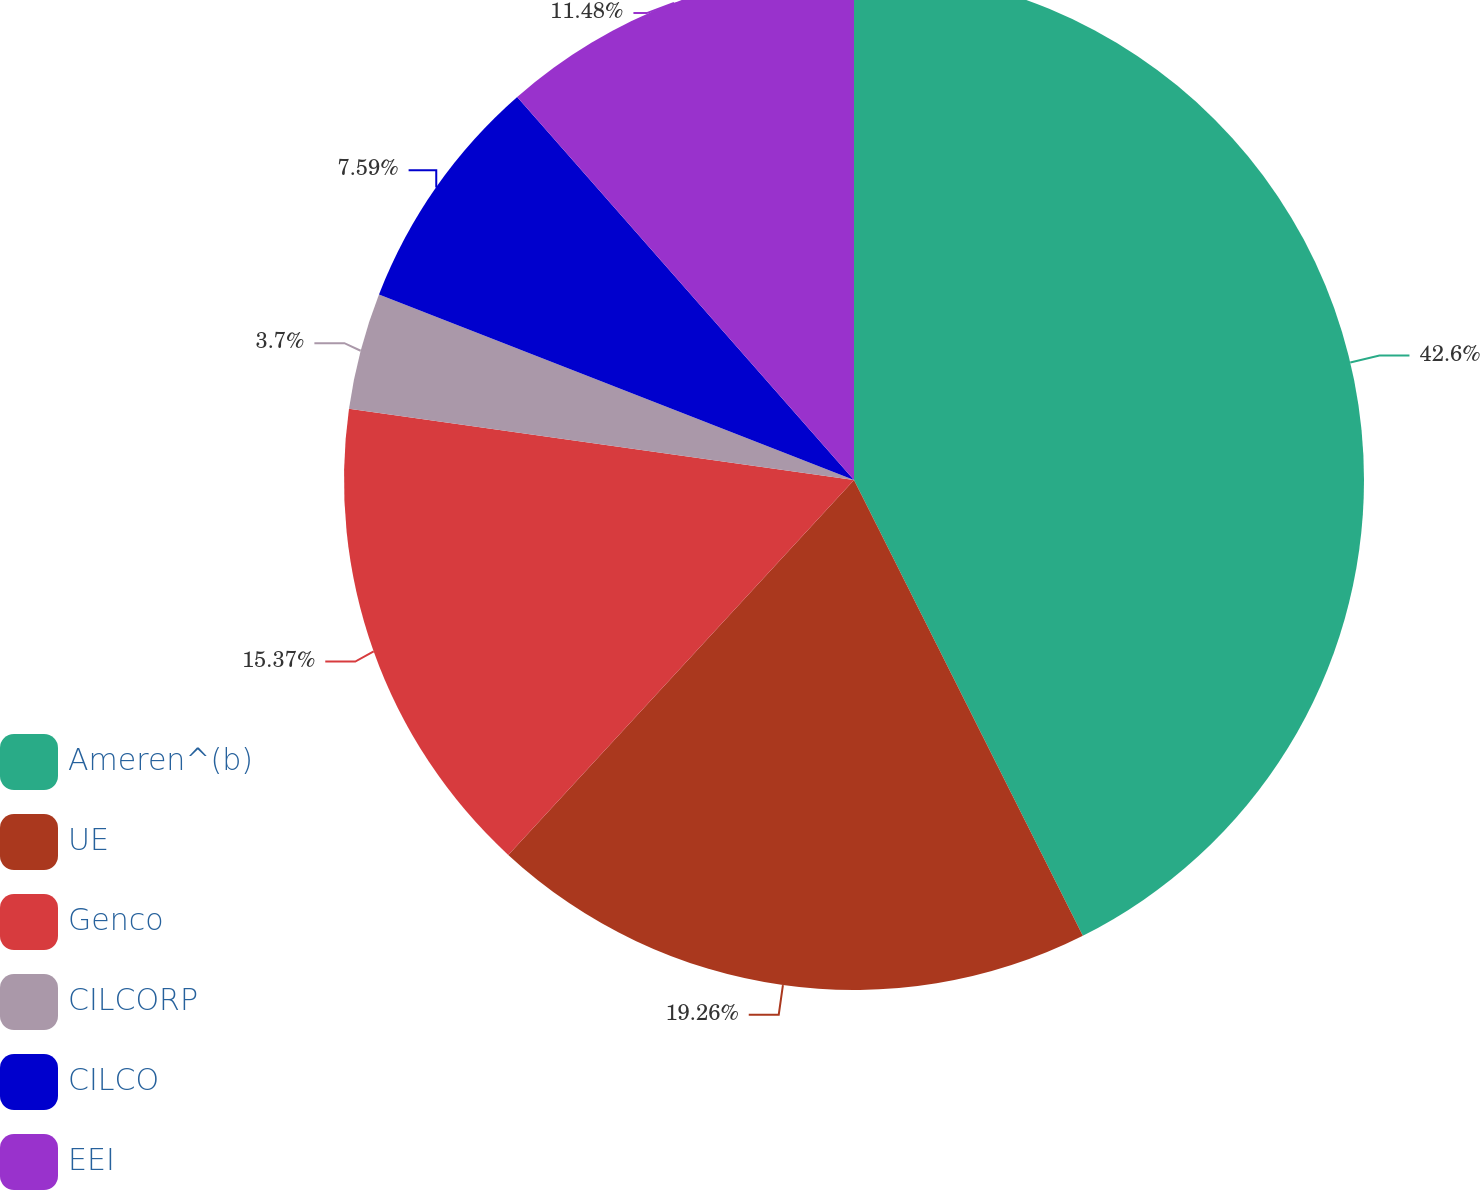<chart> <loc_0><loc_0><loc_500><loc_500><pie_chart><fcel>Ameren^(b)<fcel>UE<fcel>Genco<fcel>CILCORP<fcel>CILCO<fcel>EEI<nl><fcel>42.59%<fcel>19.26%<fcel>15.37%<fcel>3.7%<fcel>7.59%<fcel>11.48%<nl></chart> 